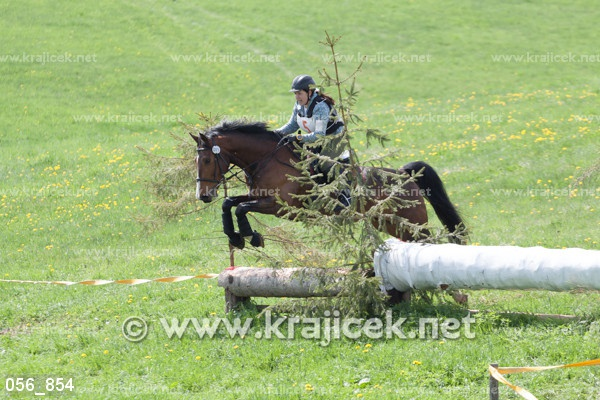Describe the objects in this image and their specific colors. I can see horse in lightgreen, black, gray, and olive tones and people in lightgreen, gray, black, darkgray, and lightgray tones in this image. 